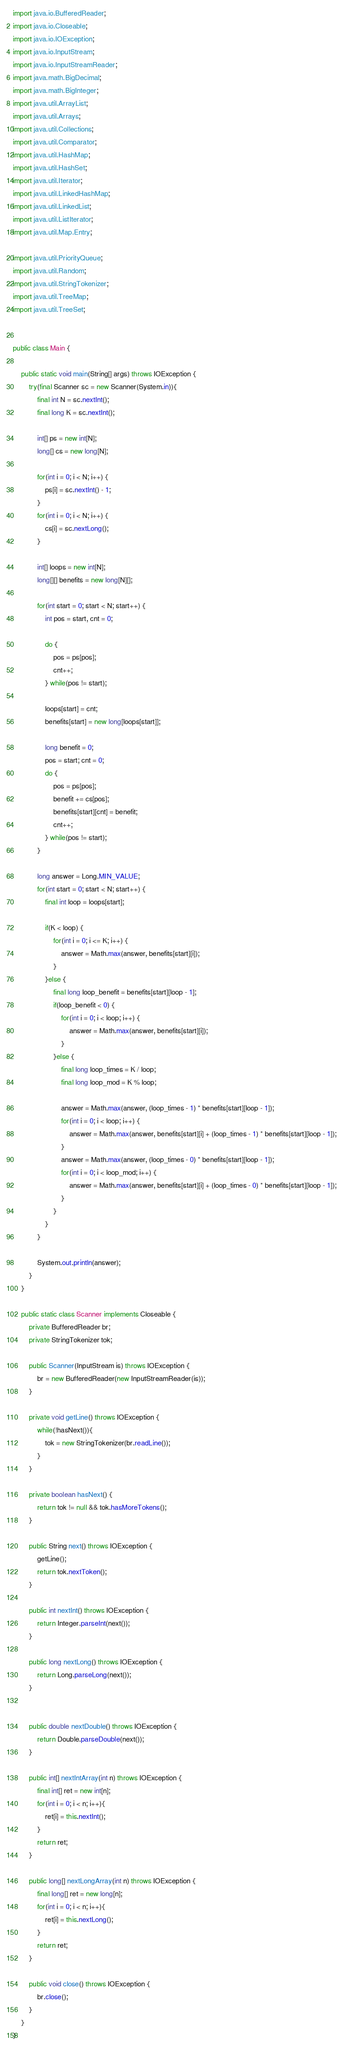Convert code to text. <code><loc_0><loc_0><loc_500><loc_500><_Java_>import java.io.BufferedReader;
import java.io.Closeable;
import java.io.IOException;
import java.io.InputStream;
import java.io.InputStreamReader;
import java.math.BigDecimal;
import java.math.BigInteger;
import java.util.ArrayList;
import java.util.Arrays;
import java.util.Collections;
import java.util.Comparator;
import java.util.HashMap;
import java.util.HashSet;
import java.util.Iterator;
import java.util.LinkedHashMap;
import java.util.LinkedList;
import java.util.ListIterator;
import java.util.Map.Entry;

import java.util.PriorityQueue;
import java.util.Random;
import java.util.StringTokenizer;
import java.util.TreeMap;
import java.util.TreeSet;


public class Main {
	
	public static void main(String[] args) throws IOException {	
		try(final Scanner sc = new Scanner(System.in)){
			final int N = sc.nextInt();
			final long K = sc.nextInt();
			
			int[] ps = new int[N];
			long[] cs = new long[N];
			
			for(int i = 0; i < N; i++) {
				ps[i] = sc.nextInt() - 1;
			}
			for(int i = 0; i < N; i++) {
				cs[i] = sc.nextLong();
			}
			
			int[] loops = new int[N];
			long[][] benefits = new long[N][];
			
			for(int start = 0; start < N; start++) {
				int pos = start, cnt = 0;
				
				do {
					pos = ps[pos];
					cnt++;
				} while(pos != start);
				
				loops[start] = cnt;
				benefits[start] = new long[loops[start]];

				long benefit = 0;
				pos = start; cnt = 0;
				do {
					pos = ps[pos];
					benefit += cs[pos];
					benefits[start][cnt] = benefit;
					cnt++;
				} while(pos != start);
			}
			
			long answer = Long.MIN_VALUE;
			for(int start = 0; start < N; start++) {
				final int loop = loops[start];
				
				if(K < loop) {
					for(int i = 0; i <= K; i++) {
						answer = Math.max(answer, benefits[start][i]);
					}
				}else {
					final long loop_benefit = benefits[start][loop - 1];
					if(loop_benefit < 0) {
						for(int i = 0; i < loop; i++) {
							answer = Math.max(answer, benefits[start][i]);
						}
					}else {
						final long loop_times = K / loop;
						final long loop_mod = K % loop;
						
						answer = Math.max(answer, (loop_times - 1) * benefits[start][loop - 1]);
						for(int i = 0; i < loop; i++) {
							answer = Math.max(answer, benefits[start][i] + (loop_times - 1) * benefits[start][loop - 1]);
						}
						answer = Math.max(answer, (loop_times - 0) * benefits[start][loop - 1]);
						for(int i = 0; i < loop_mod; i++) {
							answer = Math.max(answer, benefits[start][i] + (loop_times - 0) * benefits[start][loop - 1]);
						}
					}
				}
			}
			
			System.out.println(answer);
		}
	}

	public static class Scanner implements Closeable {
		private BufferedReader br;
		private StringTokenizer tok;

		public Scanner(InputStream is) throws IOException {
			br = new BufferedReader(new InputStreamReader(is));
		}

		private void getLine() throws IOException {
			while(!hasNext()){
				tok = new StringTokenizer(br.readLine());
			}
		}

		private boolean hasNext() {
			return tok != null && tok.hasMoreTokens();
		}

		public String next() throws IOException {
			getLine();
			return tok.nextToken();
		}

		public int nextInt() throws IOException {
			return Integer.parseInt(next());
		}

		public long nextLong() throws IOException {
			return Long.parseLong(next());
		}
		

		public double nextDouble() throws IOException {
			return Double.parseDouble(next());
		}

		public int[] nextIntArray(int n) throws IOException {
			final int[] ret = new int[n];
			for(int i = 0; i < n; i++){
				ret[i] = this.nextInt();
			}
			return ret;
		}

		public long[] nextLongArray(int n) throws IOException {
			final long[] ret = new long[n];
			for(int i = 0; i < n; i++){
				ret[i] = this.nextLong();
			}
			return ret;
		}

		public void close() throws IOException {
			br.close();
		}
	}
}
</code> 